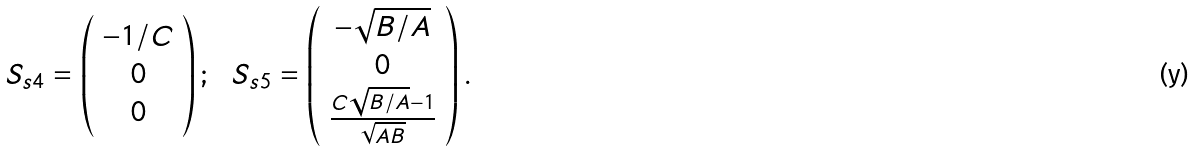<formula> <loc_0><loc_0><loc_500><loc_500>S _ { s 4 } = \left ( \begin{array} { c } - 1 / C \\ 0 \\ 0 \end{array} \right ) ; \ \ S _ { s 5 } = \left ( \begin{array} { c } - \sqrt { B / A } \\ 0 \\ \frac { C \sqrt { B / A } - 1 } { \sqrt { A B } } \end{array} \right ) .</formula> 